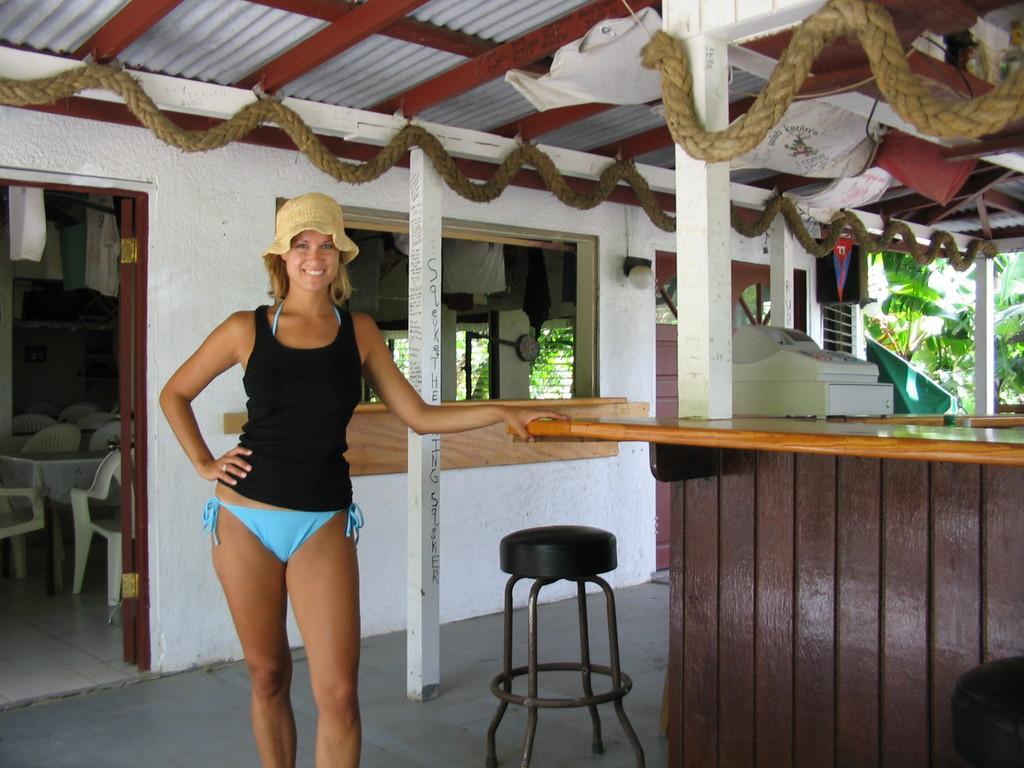In one or two sentences, can you explain what this image depicts? This is a woman standing. This is a stool,and this looks like a billing machine placed on the desk. This looks like another room with empty chairs and tables. 